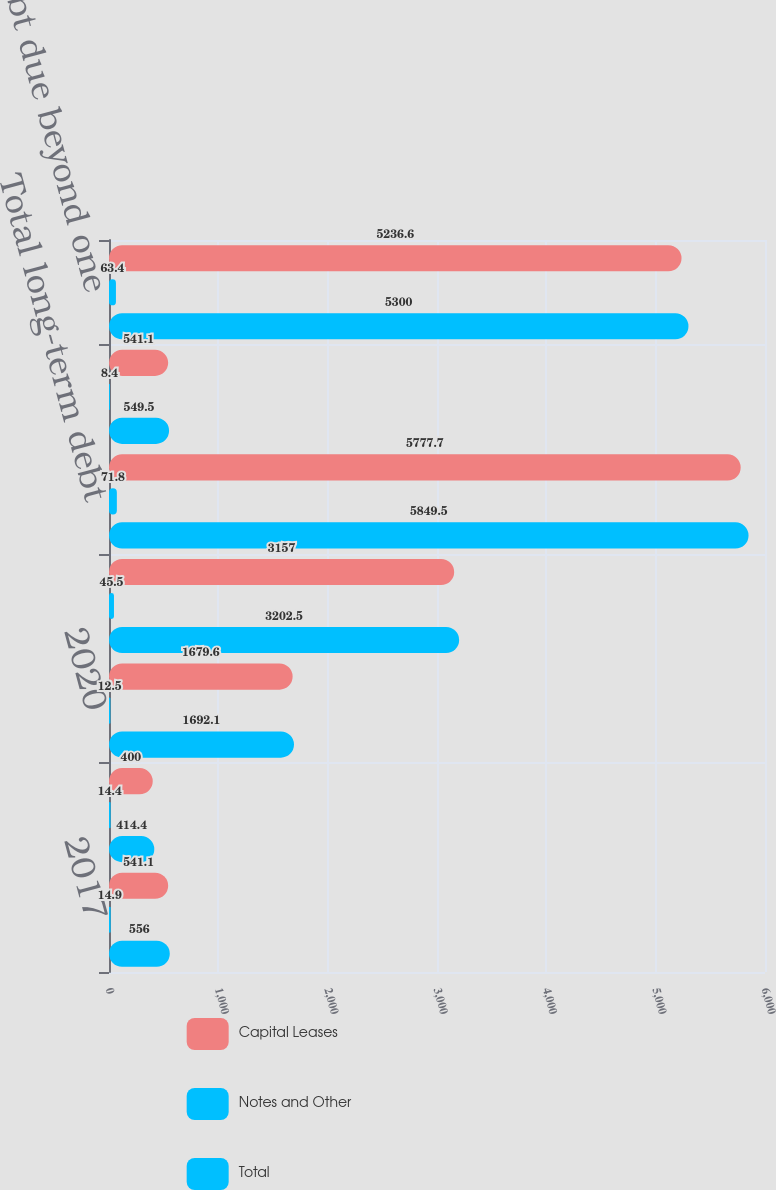<chart> <loc_0><loc_0><loc_500><loc_500><stacked_bar_chart><ecel><fcel>2017<fcel>2018<fcel>2020<fcel>Thereafter<fcel>Total long-term debt<fcel>Less current portion<fcel>Long-term debt due beyond one<nl><fcel>Capital Leases<fcel>541.1<fcel>400<fcel>1679.6<fcel>3157<fcel>5777.7<fcel>541.1<fcel>5236.6<nl><fcel>Notes and Other<fcel>14.9<fcel>14.4<fcel>12.5<fcel>45.5<fcel>71.8<fcel>8.4<fcel>63.4<nl><fcel>Total<fcel>556<fcel>414.4<fcel>1692.1<fcel>3202.5<fcel>5849.5<fcel>549.5<fcel>5300<nl></chart> 